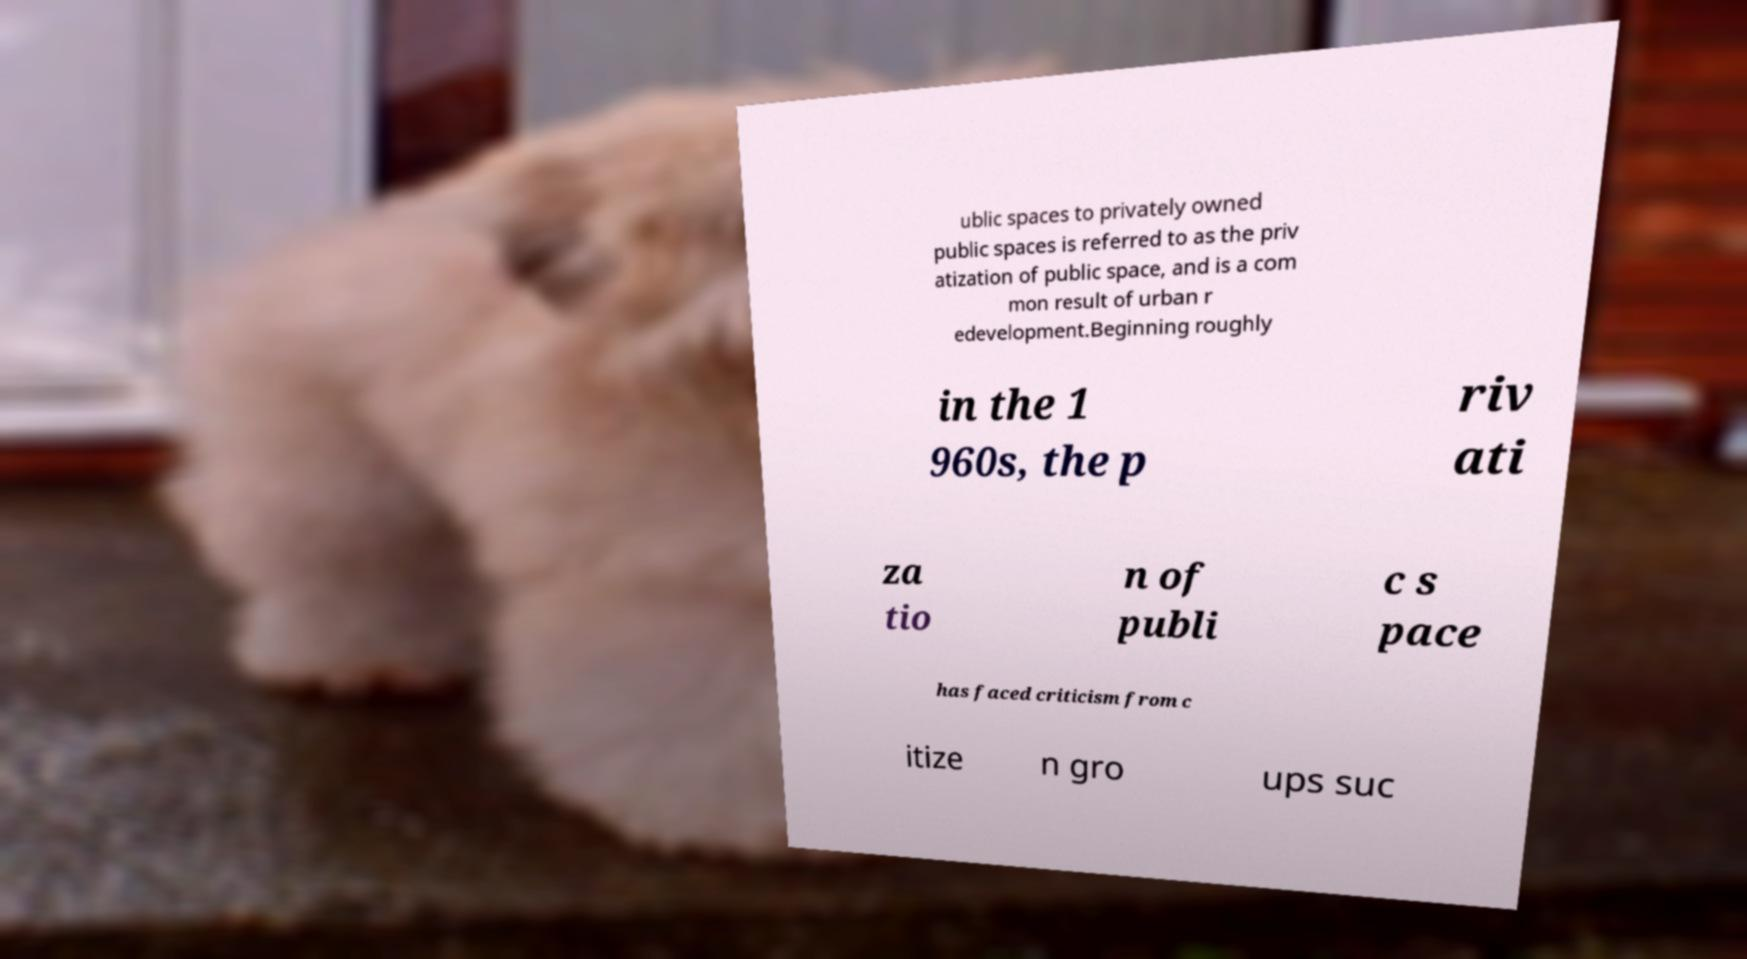Please identify and transcribe the text found in this image. ublic spaces to privately owned public spaces is referred to as the priv atization of public space, and is a com mon result of urban r edevelopment.Beginning roughly in the 1 960s, the p riv ati za tio n of publi c s pace has faced criticism from c itize n gro ups suc 